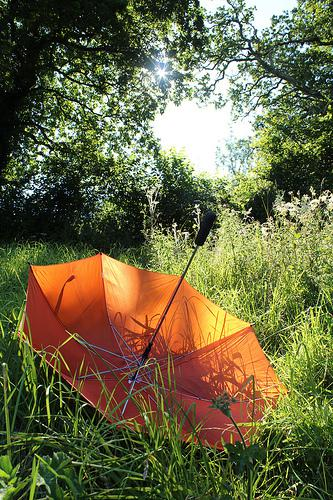Question: where was this picture taken?
Choices:
A. A school.
B. Field.
C. A beach.
D. A street.
Answer with the letter. Answer: B Question: what color handle does the umbrella have?
Choices:
A. Blue.
B. Black.
C. Brown.
D. Gray.
Answer with the letter. Answer: B Question: what color are the leaves on the trees?
Choices:
A. Brown.
B. Yellow.
C. Green.
D. Red.
Answer with the letter. Answer: C Question: why are there shadows on the umbrella?
Choices:
A. Storm is coming.
B. People blocking sun.
C. Birds overhead.
D. It's sunny.
Answer with the letter. Answer: D Question: what is shining through the trees?
Choices:
A. The sun.
B. A bright light.
C. The moon.
D. The stars.
Answer with the letter. Answer: A 